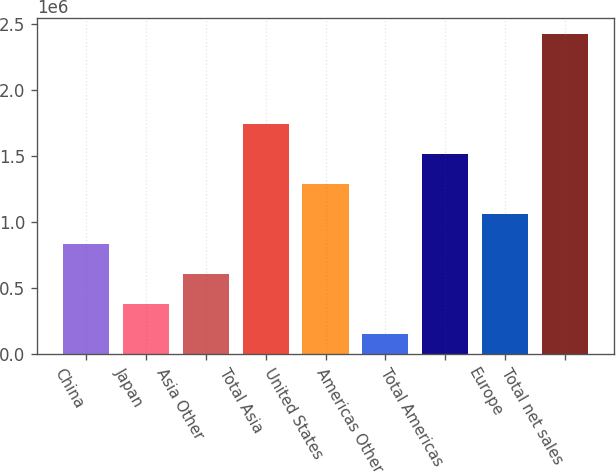<chart> <loc_0><loc_0><loc_500><loc_500><bar_chart><fcel>China<fcel>Japan<fcel>Asia Other<fcel>Total Asia<fcel>United States<fcel>Americas Other<fcel>Total Americas<fcel>Europe<fcel>Total net sales<nl><fcel>832085<fcel>378416<fcel>605251<fcel>1.73942e+06<fcel>1.28576e+06<fcel>151581<fcel>1.51259e+06<fcel>1.05892e+06<fcel>2.41993e+06<nl></chart> 